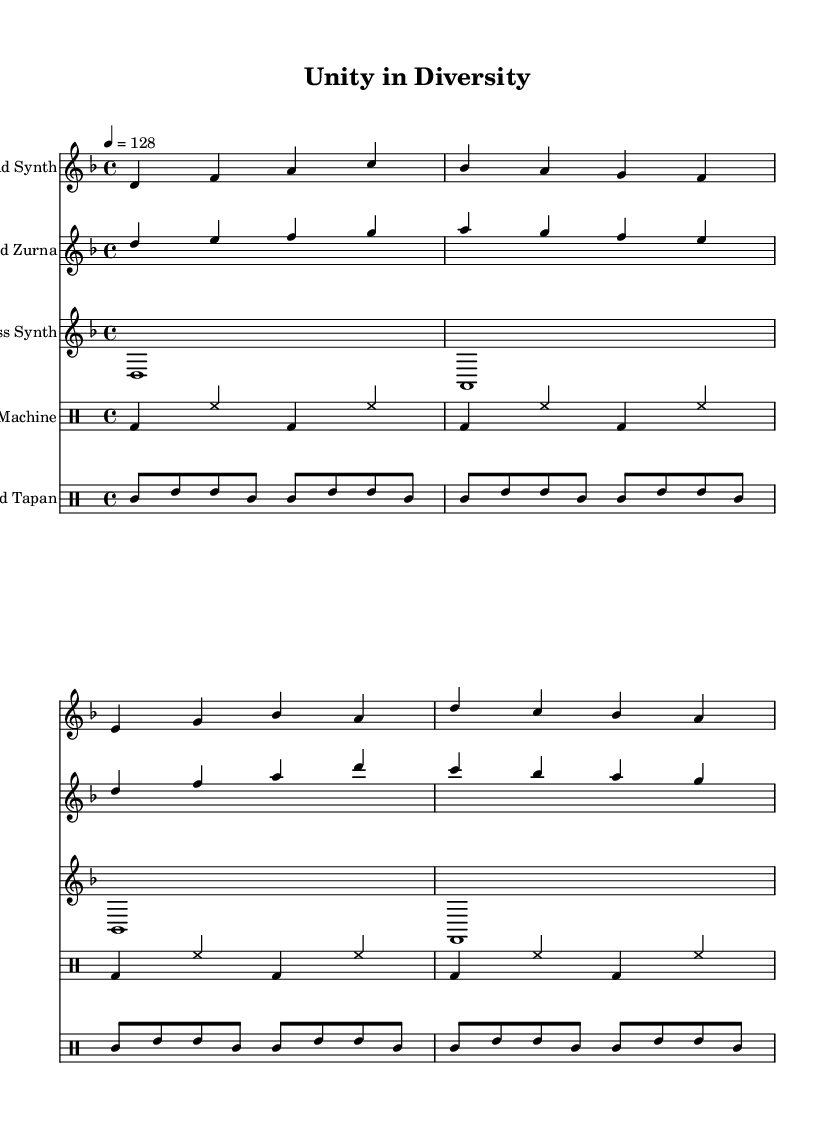What is the key signature of this music? The key signature indicated at the beginning of the score is D minor, which is represented by a single flat (B flat).
Answer: D minor What is the time signature of this music? The time signature displayed at the beginning shows a 4/4 measure, meaning there are four beats per measure and the quarter note gets one beat.
Answer: 4/4 What is the tempo marking for this music? The tempo marking provided indicates a speed of 128 beats per minute, which is typical for electronic music to ensure a danceable rhythm.
Answer: 128 How many different instruments are used in the composition? The score includes a lead synth, sampled zurna, bass synth, a drum machine, and a sampled tapan, making a total of five instruments.
Answer: Five Which synthesizer plays the lowest notes in the composition? The bass synth plays the lowest notes as it is specifically designed to synthesize low-frequency sounds and bass lines.
Answer: Bass synth What rhythmic element is repeated in the drum machine part? The drum machine part features a repeating kick and hi-hat pattern, which is common in electronic music to create a steady drive.
Answer: Kick and hi-hat What cultural instrument is sampled in this piece? The zurna, a traditional wind instrument common in Balkan music, is sampled and included to infuse cultural elements into the electronic genre.
Answer: Zurna 